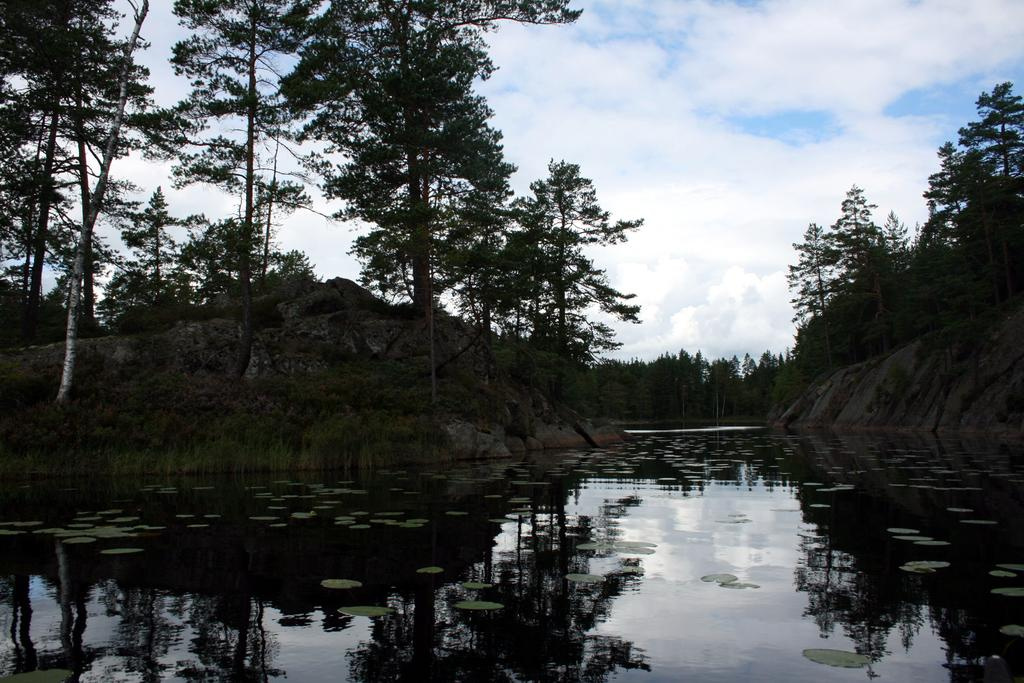What is visible in the front of the image? There is water in the front of the image. What can be seen in the background of the image? There are trees in the background of the image. How would you describe the sky in the image? The sky is cloudy in the image. What type of furniture is present near the seashore in the image? There is no seashore or furniture present in the image. How many trees are visible in the image? The provided facts do not specify the number of trees visible in the image, only that there are trees in the background. 